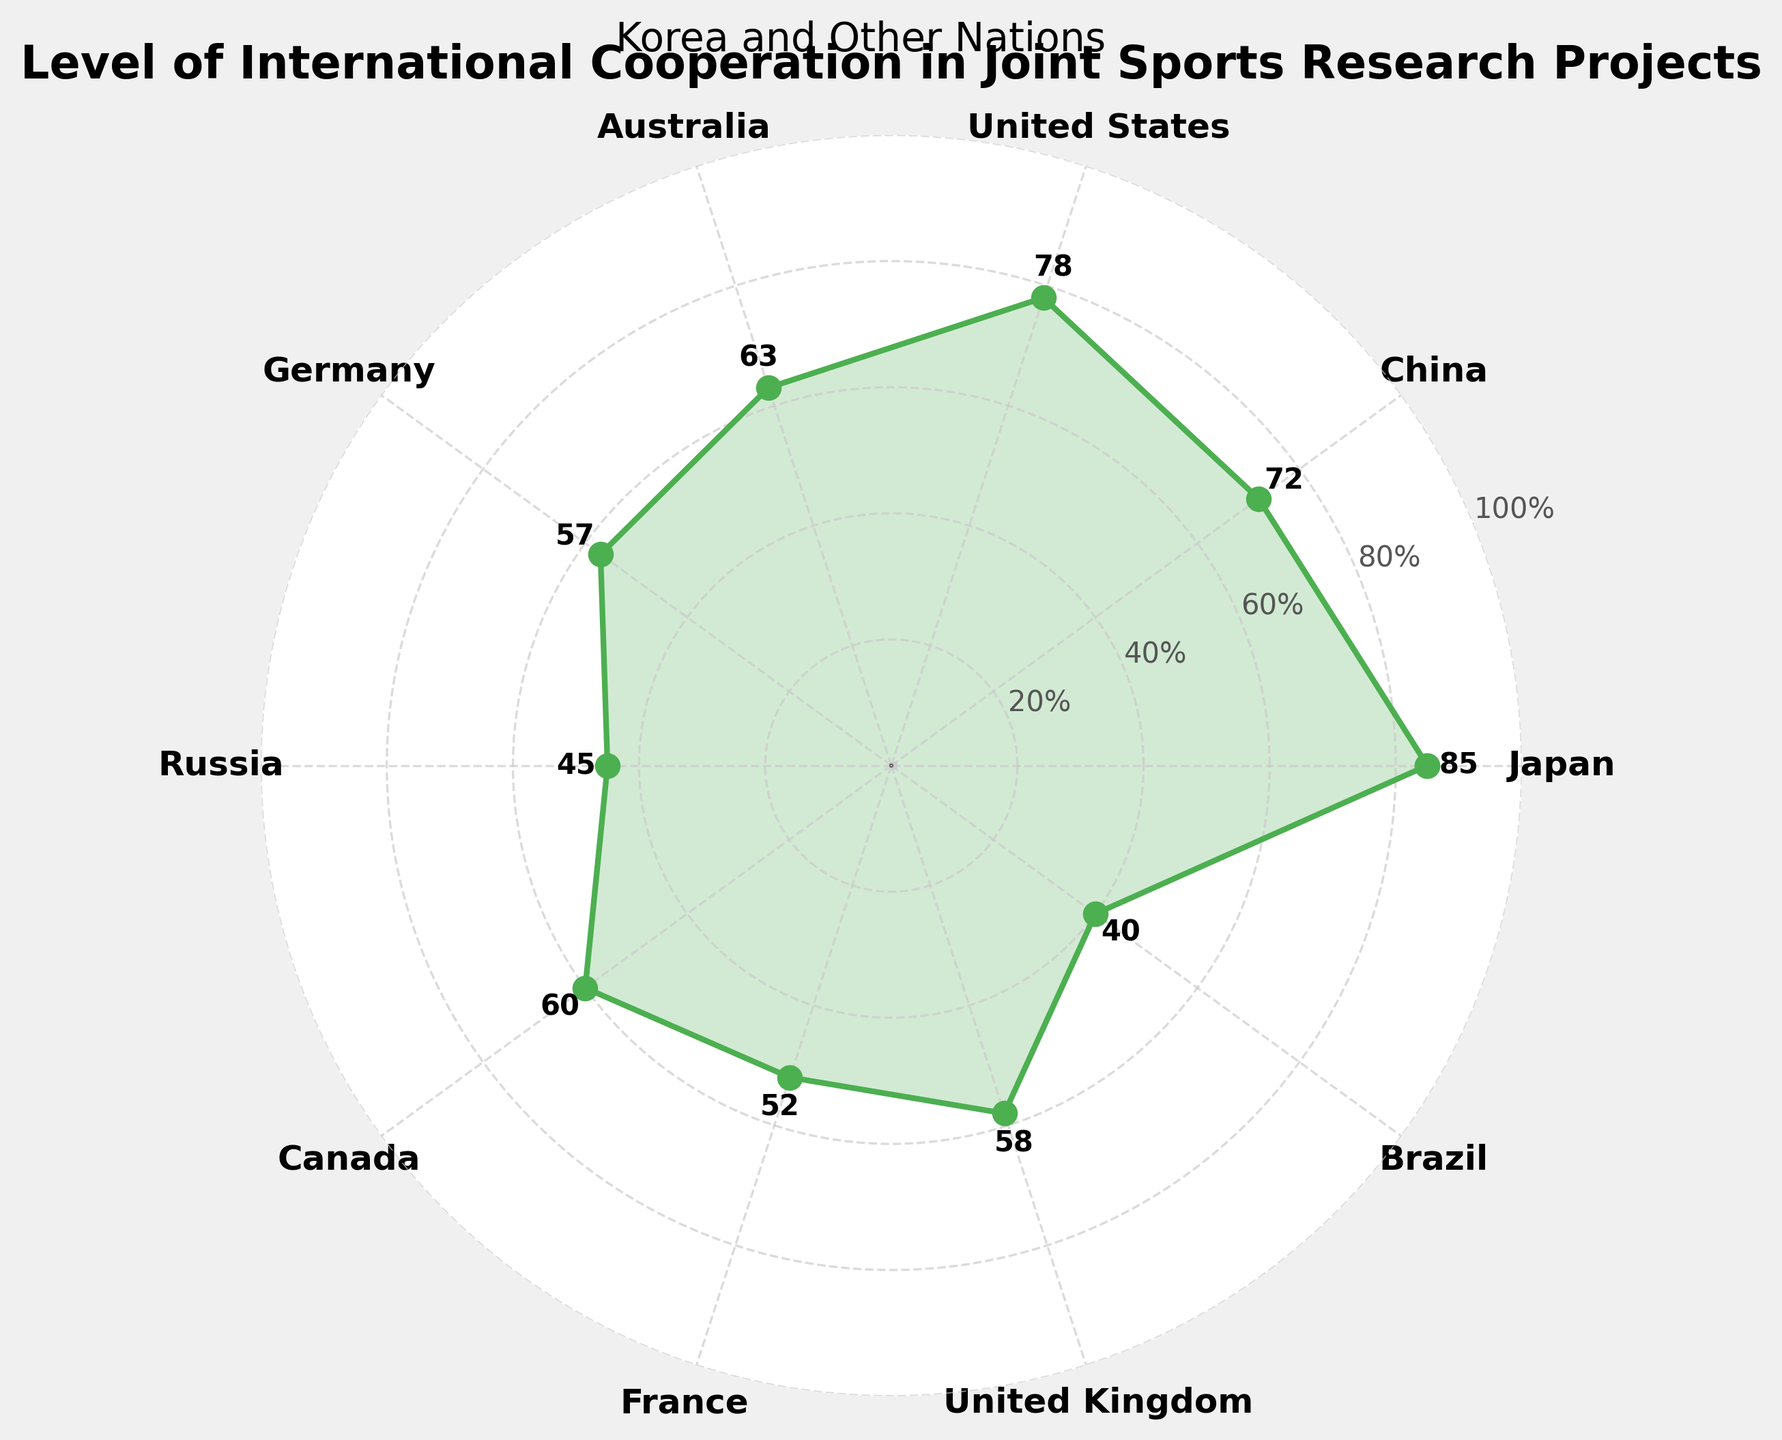Which country has the highest level of cooperation with Korea in joint sports research projects? Looking at the figure, Japan shows the highest cooperation level at 85%.
Answer: Japan Which country has the lowest level of cooperation with Korea in joint sports research projects? According to the figure, Brazil shows the lowest cooperation level at 40%.
Answer: Brazil What is the cooperation level between Korea and the United States in joint sports research projects? The figure indicates that the cooperation level between Korea and the United States is 78%.
Answer: 78% How many countries have a cooperation level above 70%? From the figure, Japan (85%), China (72%), and United States (78%) have levels above 70%. This makes 3 countries.
Answer: 3 What is the range of cooperation levels across all countries? The range is found by subtracting the minimum level (Brazil, 40%) from the maximum level (Japan, 85%). Thus, 85% - 40% = 45%.
Answer: 45% Which country has a cooperation level closest to the median of all levels? The median value of the cooperation levels is the middle value when sorted: [40, 45, 52, 57, 58, 60, 63, 72, 78, 85]. The middle value is 58%, and the United Kingdom has the closest level at 58%.
Answer: United Kingdom Between Germany and France, which country has a higher cooperation level? Referring to the figure, Germany has a level of 57%, while France has a level of 52%. Thus, Germany has a higher level.
Answer: Germany Calculate the average cooperation level across all countries. Sum of cooperation levels = 85 + 72 + 78 + 63 + 57 + 45 + 60 + 52 + 58 + 40 = 610. Number of countries = 10. Average = 610 / 10 = 61%.
Answer: 61% How many countries have a cooperation level between 50% and 70%? According to the figure, the countries are Germany (57%), Canada (60%), France (52%), United Kingdom (58%), and Australia (63%). In total, there are 5 countries in this range.
Answer: 5 Is there a greater variation in cooperation levels among Asian countries (Japan, China) compared to European countries (Germany, France, United Kingdom)? Variation for Asian countries: 85% (Japan) - 72% (China) = 13%. Variation for European countries: 58% (UK) - 52% (France) = 6%. Since 13% > 6%, variation is greater among Asian countries.
Answer: Yes 